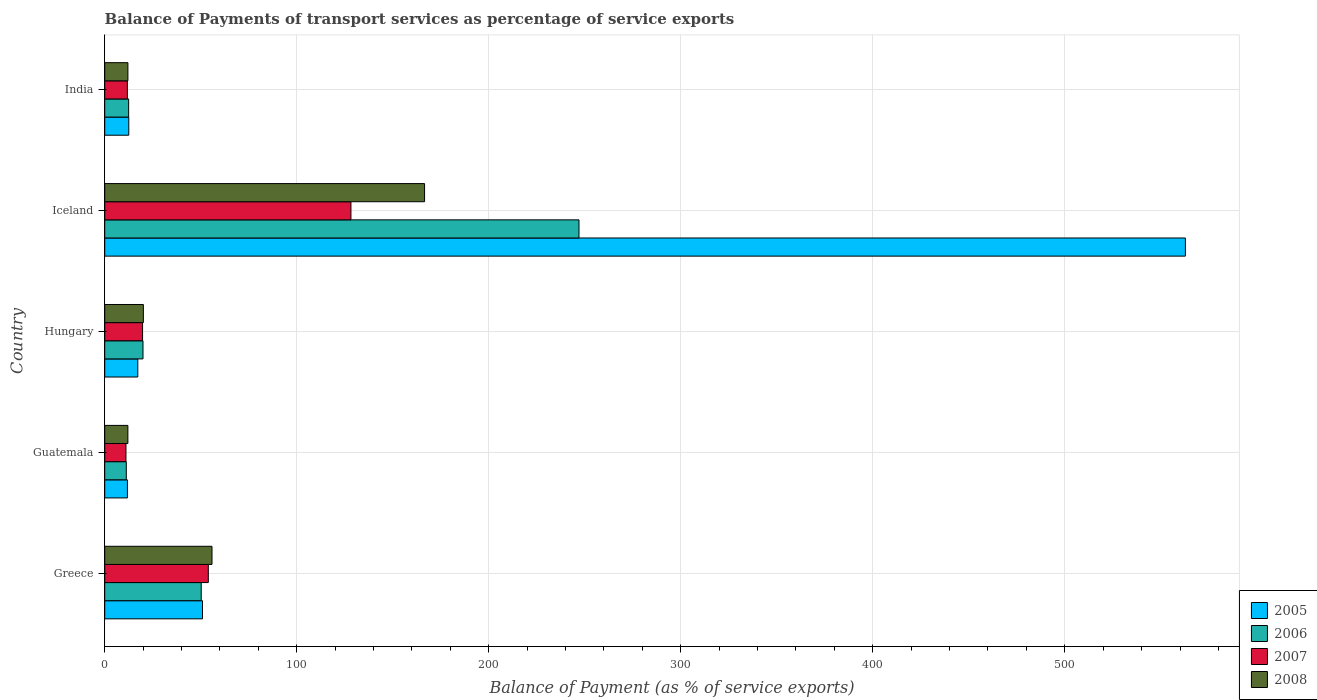Are the number of bars per tick equal to the number of legend labels?
Give a very brief answer. Yes. Are the number of bars on each tick of the Y-axis equal?
Your answer should be very brief. Yes. How many bars are there on the 2nd tick from the top?
Offer a very short reply. 4. How many bars are there on the 4th tick from the bottom?
Give a very brief answer. 4. What is the balance of payments of transport services in 2007 in Hungary?
Your answer should be very brief. 19.71. Across all countries, what is the maximum balance of payments of transport services in 2008?
Offer a terse response. 166.58. Across all countries, what is the minimum balance of payments of transport services in 2005?
Offer a terse response. 11.81. In which country was the balance of payments of transport services in 2008 maximum?
Your response must be concise. Iceland. In which country was the balance of payments of transport services in 2005 minimum?
Ensure brevity in your answer.  Guatemala. What is the total balance of payments of transport services in 2008 in the graph?
Your answer should be very brief. 266.71. What is the difference between the balance of payments of transport services in 2007 in Hungary and that in India?
Your response must be concise. 7.92. What is the difference between the balance of payments of transport services in 2007 in Greece and the balance of payments of transport services in 2008 in Iceland?
Keep it short and to the point. -112.63. What is the average balance of payments of transport services in 2006 per country?
Your answer should be compact. 68.18. What is the difference between the balance of payments of transport services in 2007 and balance of payments of transport services in 2006 in Iceland?
Provide a succinct answer. -118.77. In how many countries, is the balance of payments of transport services in 2006 greater than 260 %?
Your answer should be very brief. 0. What is the ratio of the balance of payments of transport services in 2005 in Guatemala to that in Hungary?
Provide a succinct answer. 0.69. Is the balance of payments of transport services in 2008 in Hungary less than that in India?
Your answer should be very brief. No. Is the difference between the balance of payments of transport services in 2007 in Greece and Iceland greater than the difference between the balance of payments of transport services in 2006 in Greece and Iceland?
Provide a short and direct response. Yes. What is the difference between the highest and the second highest balance of payments of transport services in 2008?
Ensure brevity in your answer.  110.71. What is the difference between the highest and the lowest balance of payments of transport services in 2005?
Offer a terse response. 550.99. In how many countries, is the balance of payments of transport services in 2008 greater than the average balance of payments of transport services in 2008 taken over all countries?
Your answer should be compact. 2. Is it the case that in every country, the sum of the balance of payments of transport services in 2006 and balance of payments of transport services in 2005 is greater than the sum of balance of payments of transport services in 2008 and balance of payments of transport services in 2007?
Your answer should be compact. No. Is it the case that in every country, the sum of the balance of payments of transport services in 2005 and balance of payments of transport services in 2007 is greater than the balance of payments of transport services in 2008?
Make the answer very short. Yes. What is the difference between two consecutive major ticks on the X-axis?
Keep it short and to the point. 100. Does the graph contain any zero values?
Offer a very short reply. No. Does the graph contain grids?
Provide a short and direct response. Yes. Where does the legend appear in the graph?
Your answer should be compact. Bottom right. How many legend labels are there?
Ensure brevity in your answer.  4. How are the legend labels stacked?
Your answer should be compact. Vertical. What is the title of the graph?
Give a very brief answer. Balance of Payments of transport services as percentage of service exports. What is the label or title of the X-axis?
Ensure brevity in your answer.  Balance of Payment (as % of service exports). What is the label or title of the Y-axis?
Provide a short and direct response. Country. What is the Balance of Payment (as % of service exports) in 2005 in Greece?
Give a very brief answer. 50.92. What is the Balance of Payment (as % of service exports) of 2006 in Greece?
Your response must be concise. 50.25. What is the Balance of Payment (as % of service exports) of 2007 in Greece?
Your answer should be compact. 53.95. What is the Balance of Payment (as % of service exports) in 2008 in Greece?
Your answer should be compact. 55.87. What is the Balance of Payment (as % of service exports) of 2005 in Guatemala?
Provide a succinct answer. 11.81. What is the Balance of Payment (as % of service exports) of 2006 in Guatemala?
Give a very brief answer. 11.24. What is the Balance of Payment (as % of service exports) in 2007 in Guatemala?
Your answer should be compact. 11.06. What is the Balance of Payment (as % of service exports) in 2008 in Guatemala?
Your answer should be compact. 12.06. What is the Balance of Payment (as % of service exports) of 2005 in Hungary?
Keep it short and to the point. 17.23. What is the Balance of Payment (as % of service exports) in 2006 in Hungary?
Offer a very short reply. 19.93. What is the Balance of Payment (as % of service exports) in 2007 in Hungary?
Provide a short and direct response. 19.71. What is the Balance of Payment (as % of service exports) of 2008 in Hungary?
Ensure brevity in your answer.  20.12. What is the Balance of Payment (as % of service exports) of 2005 in Iceland?
Give a very brief answer. 562.81. What is the Balance of Payment (as % of service exports) of 2006 in Iceland?
Offer a terse response. 247. What is the Balance of Payment (as % of service exports) of 2007 in Iceland?
Ensure brevity in your answer.  128.23. What is the Balance of Payment (as % of service exports) of 2008 in Iceland?
Provide a succinct answer. 166.58. What is the Balance of Payment (as % of service exports) in 2005 in India?
Your answer should be compact. 12.53. What is the Balance of Payment (as % of service exports) of 2006 in India?
Keep it short and to the point. 12.46. What is the Balance of Payment (as % of service exports) of 2007 in India?
Ensure brevity in your answer.  11.8. What is the Balance of Payment (as % of service exports) of 2008 in India?
Provide a succinct answer. 12.07. Across all countries, what is the maximum Balance of Payment (as % of service exports) of 2005?
Your answer should be very brief. 562.81. Across all countries, what is the maximum Balance of Payment (as % of service exports) in 2006?
Give a very brief answer. 247. Across all countries, what is the maximum Balance of Payment (as % of service exports) of 2007?
Your response must be concise. 128.23. Across all countries, what is the maximum Balance of Payment (as % of service exports) of 2008?
Your answer should be very brief. 166.58. Across all countries, what is the minimum Balance of Payment (as % of service exports) of 2005?
Give a very brief answer. 11.81. Across all countries, what is the minimum Balance of Payment (as % of service exports) in 2006?
Provide a short and direct response. 11.24. Across all countries, what is the minimum Balance of Payment (as % of service exports) of 2007?
Give a very brief answer. 11.06. Across all countries, what is the minimum Balance of Payment (as % of service exports) in 2008?
Give a very brief answer. 12.06. What is the total Balance of Payment (as % of service exports) in 2005 in the graph?
Make the answer very short. 655.29. What is the total Balance of Payment (as % of service exports) in 2006 in the graph?
Provide a short and direct response. 340.88. What is the total Balance of Payment (as % of service exports) of 2007 in the graph?
Your answer should be very brief. 224.75. What is the total Balance of Payment (as % of service exports) of 2008 in the graph?
Your response must be concise. 266.71. What is the difference between the Balance of Payment (as % of service exports) in 2005 in Greece and that in Guatemala?
Give a very brief answer. 39.1. What is the difference between the Balance of Payment (as % of service exports) of 2006 in Greece and that in Guatemala?
Ensure brevity in your answer.  39.02. What is the difference between the Balance of Payment (as % of service exports) of 2007 in Greece and that in Guatemala?
Your response must be concise. 42.9. What is the difference between the Balance of Payment (as % of service exports) of 2008 in Greece and that in Guatemala?
Make the answer very short. 43.81. What is the difference between the Balance of Payment (as % of service exports) in 2005 in Greece and that in Hungary?
Your response must be concise. 33.69. What is the difference between the Balance of Payment (as % of service exports) of 2006 in Greece and that in Hungary?
Offer a terse response. 30.32. What is the difference between the Balance of Payment (as % of service exports) of 2007 in Greece and that in Hungary?
Ensure brevity in your answer.  34.24. What is the difference between the Balance of Payment (as % of service exports) in 2008 in Greece and that in Hungary?
Your response must be concise. 35.75. What is the difference between the Balance of Payment (as % of service exports) of 2005 in Greece and that in Iceland?
Provide a short and direct response. -511.89. What is the difference between the Balance of Payment (as % of service exports) of 2006 in Greece and that in Iceland?
Your answer should be very brief. -196.74. What is the difference between the Balance of Payment (as % of service exports) of 2007 in Greece and that in Iceland?
Your answer should be very brief. -74.27. What is the difference between the Balance of Payment (as % of service exports) in 2008 in Greece and that in Iceland?
Your response must be concise. -110.71. What is the difference between the Balance of Payment (as % of service exports) of 2005 in Greece and that in India?
Offer a terse response. 38.39. What is the difference between the Balance of Payment (as % of service exports) in 2006 in Greece and that in India?
Keep it short and to the point. 37.79. What is the difference between the Balance of Payment (as % of service exports) of 2007 in Greece and that in India?
Provide a short and direct response. 42.16. What is the difference between the Balance of Payment (as % of service exports) of 2008 in Greece and that in India?
Make the answer very short. 43.79. What is the difference between the Balance of Payment (as % of service exports) in 2005 in Guatemala and that in Hungary?
Ensure brevity in your answer.  -5.42. What is the difference between the Balance of Payment (as % of service exports) of 2006 in Guatemala and that in Hungary?
Keep it short and to the point. -8.7. What is the difference between the Balance of Payment (as % of service exports) in 2007 in Guatemala and that in Hungary?
Your answer should be compact. -8.66. What is the difference between the Balance of Payment (as % of service exports) of 2008 in Guatemala and that in Hungary?
Your answer should be compact. -8.06. What is the difference between the Balance of Payment (as % of service exports) in 2005 in Guatemala and that in Iceland?
Provide a succinct answer. -550.99. What is the difference between the Balance of Payment (as % of service exports) of 2006 in Guatemala and that in Iceland?
Provide a succinct answer. -235.76. What is the difference between the Balance of Payment (as % of service exports) in 2007 in Guatemala and that in Iceland?
Make the answer very short. -117.17. What is the difference between the Balance of Payment (as % of service exports) of 2008 in Guatemala and that in Iceland?
Ensure brevity in your answer.  -154.52. What is the difference between the Balance of Payment (as % of service exports) of 2005 in Guatemala and that in India?
Your answer should be very brief. -0.71. What is the difference between the Balance of Payment (as % of service exports) in 2006 in Guatemala and that in India?
Provide a succinct answer. -1.22. What is the difference between the Balance of Payment (as % of service exports) in 2007 in Guatemala and that in India?
Keep it short and to the point. -0.74. What is the difference between the Balance of Payment (as % of service exports) in 2008 in Guatemala and that in India?
Make the answer very short. -0.01. What is the difference between the Balance of Payment (as % of service exports) of 2005 in Hungary and that in Iceland?
Provide a succinct answer. -545.58. What is the difference between the Balance of Payment (as % of service exports) in 2006 in Hungary and that in Iceland?
Keep it short and to the point. -227.06. What is the difference between the Balance of Payment (as % of service exports) of 2007 in Hungary and that in Iceland?
Ensure brevity in your answer.  -108.51. What is the difference between the Balance of Payment (as % of service exports) in 2008 in Hungary and that in Iceland?
Your response must be concise. -146.46. What is the difference between the Balance of Payment (as % of service exports) of 2005 in Hungary and that in India?
Your response must be concise. 4.7. What is the difference between the Balance of Payment (as % of service exports) in 2006 in Hungary and that in India?
Your answer should be very brief. 7.47. What is the difference between the Balance of Payment (as % of service exports) in 2007 in Hungary and that in India?
Your answer should be very brief. 7.92. What is the difference between the Balance of Payment (as % of service exports) in 2008 in Hungary and that in India?
Your response must be concise. 8.05. What is the difference between the Balance of Payment (as % of service exports) of 2005 in Iceland and that in India?
Keep it short and to the point. 550.28. What is the difference between the Balance of Payment (as % of service exports) in 2006 in Iceland and that in India?
Give a very brief answer. 234.54. What is the difference between the Balance of Payment (as % of service exports) of 2007 in Iceland and that in India?
Provide a short and direct response. 116.43. What is the difference between the Balance of Payment (as % of service exports) in 2008 in Iceland and that in India?
Your answer should be compact. 154.51. What is the difference between the Balance of Payment (as % of service exports) in 2005 in Greece and the Balance of Payment (as % of service exports) in 2006 in Guatemala?
Your answer should be very brief. 39.68. What is the difference between the Balance of Payment (as % of service exports) of 2005 in Greece and the Balance of Payment (as % of service exports) of 2007 in Guatemala?
Ensure brevity in your answer.  39.86. What is the difference between the Balance of Payment (as % of service exports) in 2005 in Greece and the Balance of Payment (as % of service exports) in 2008 in Guatemala?
Make the answer very short. 38.85. What is the difference between the Balance of Payment (as % of service exports) in 2006 in Greece and the Balance of Payment (as % of service exports) in 2007 in Guatemala?
Make the answer very short. 39.2. What is the difference between the Balance of Payment (as % of service exports) of 2006 in Greece and the Balance of Payment (as % of service exports) of 2008 in Guatemala?
Offer a very short reply. 38.19. What is the difference between the Balance of Payment (as % of service exports) in 2007 in Greece and the Balance of Payment (as % of service exports) in 2008 in Guatemala?
Your response must be concise. 41.89. What is the difference between the Balance of Payment (as % of service exports) in 2005 in Greece and the Balance of Payment (as % of service exports) in 2006 in Hungary?
Your answer should be compact. 30.98. What is the difference between the Balance of Payment (as % of service exports) in 2005 in Greece and the Balance of Payment (as % of service exports) in 2007 in Hungary?
Give a very brief answer. 31.2. What is the difference between the Balance of Payment (as % of service exports) of 2005 in Greece and the Balance of Payment (as % of service exports) of 2008 in Hungary?
Provide a succinct answer. 30.8. What is the difference between the Balance of Payment (as % of service exports) in 2006 in Greece and the Balance of Payment (as % of service exports) in 2007 in Hungary?
Your response must be concise. 30.54. What is the difference between the Balance of Payment (as % of service exports) of 2006 in Greece and the Balance of Payment (as % of service exports) of 2008 in Hungary?
Offer a very short reply. 30.13. What is the difference between the Balance of Payment (as % of service exports) of 2007 in Greece and the Balance of Payment (as % of service exports) of 2008 in Hungary?
Your answer should be compact. 33.83. What is the difference between the Balance of Payment (as % of service exports) in 2005 in Greece and the Balance of Payment (as % of service exports) in 2006 in Iceland?
Ensure brevity in your answer.  -196.08. What is the difference between the Balance of Payment (as % of service exports) of 2005 in Greece and the Balance of Payment (as % of service exports) of 2007 in Iceland?
Offer a very short reply. -77.31. What is the difference between the Balance of Payment (as % of service exports) of 2005 in Greece and the Balance of Payment (as % of service exports) of 2008 in Iceland?
Make the answer very short. -115.67. What is the difference between the Balance of Payment (as % of service exports) of 2006 in Greece and the Balance of Payment (as % of service exports) of 2007 in Iceland?
Make the answer very short. -77.97. What is the difference between the Balance of Payment (as % of service exports) of 2006 in Greece and the Balance of Payment (as % of service exports) of 2008 in Iceland?
Provide a short and direct response. -116.33. What is the difference between the Balance of Payment (as % of service exports) of 2007 in Greece and the Balance of Payment (as % of service exports) of 2008 in Iceland?
Make the answer very short. -112.63. What is the difference between the Balance of Payment (as % of service exports) in 2005 in Greece and the Balance of Payment (as % of service exports) in 2006 in India?
Give a very brief answer. 38.46. What is the difference between the Balance of Payment (as % of service exports) in 2005 in Greece and the Balance of Payment (as % of service exports) in 2007 in India?
Provide a succinct answer. 39.12. What is the difference between the Balance of Payment (as % of service exports) of 2005 in Greece and the Balance of Payment (as % of service exports) of 2008 in India?
Give a very brief answer. 38.84. What is the difference between the Balance of Payment (as % of service exports) in 2006 in Greece and the Balance of Payment (as % of service exports) in 2007 in India?
Make the answer very short. 38.46. What is the difference between the Balance of Payment (as % of service exports) of 2006 in Greece and the Balance of Payment (as % of service exports) of 2008 in India?
Offer a very short reply. 38.18. What is the difference between the Balance of Payment (as % of service exports) of 2007 in Greece and the Balance of Payment (as % of service exports) of 2008 in India?
Give a very brief answer. 41.88. What is the difference between the Balance of Payment (as % of service exports) in 2005 in Guatemala and the Balance of Payment (as % of service exports) in 2006 in Hungary?
Your answer should be compact. -8.12. What is the difference between the Balance of Payment (as % of service exports) of 2005 in Guatemala and the Balance of Payment (as % of service exports) of 2007 in Hungary?
Provide a succinct answer. -7.9. What is the difference between the Balance of Payment (as % of service exports) of 2005 in Guatemala and the Balance of Payment (as % of service exports) of 2008 in Hungary?
Give a very brief answer. -8.31. What is the difference between the Balance of Payment (as % of service exports) in 2006 in Guatemala and the Balance of Payment (as % of service exports) in 2007 in Hungary?
Provide a short and direct response. -8.47. What is the difference between the Balance of Payment (as % of service exports) of 2006 in Guatemala and the Balance of Payment (as % of service exports) of 2008 in Hungary?
Your answer should be compact. -8.88. What is the difference between the Balance of Payment (as % of service exports) in 2007 in Guatemala and the Balance of Payment (as % of service exports) in 2008 in Hungary?
Offer a terse response. -9.06. What is the difference between the Balance of Payment (as % of service exports) of 2005 in Guatemala and the Balance of Payment (as % of service exports) of 2006 in Iceland?
Give a very brief answer. -235.18. What is the difference between the Balance of Payment (as % of service exports) in 2005 in Guatemala and the Balance of Payment (as % of service exports) in 2007 in Iceland?
Ensure brevity in your answer.  -116.41. What is the difference between the Balance of Payment (as % of service exports) in 2005 in Guatemala and the Balance of Payment (as % of service exports) in 2008 in Iceland?
Your answer should be compact. -154.77. What is the difference between the Balance of Payment (as % of service exports) of 2006 in Guatemala and the Balance of Payment (as % of service exports) of 2007 in Iceland?
Give a very brief answer. -116.99. What is the difference between the Balance of Payment (as % of service exports) of 2006 in Guatemala and the Balance of Payment (as % of service exports) of 2008 in Iceland?
Your answer should be compact. -155.34. What is the difference between the Balance of Payment (as % of service exports) in 2007 in Guatemala and the Balance of Payment (as % of service exports) in 2008 in Iceland?
Give a very brief answer. -155.53. What is the difference between the Balance of Payment (as % of service exports) in 2005 in Guatemala and the Balance of Payment (as % of service exports) in 2006 in India?
Provide a short and direct response. -0.65. What is the difference between the Balance of Payment (as % of service exports) of 2005 in Guatemala and the Balance of Payment (as % of service exports) of 2007 in India?
Give a very brief answer. 0.02. What is the difference between the Balance of Payment (as % of service exports) in 2005 in Guatemala and the Balance of Payment (as % of service exports) in 2008 in India?
Offer a terse response. -0.26. What is the difference between the Balance of Payment (as % of service exports) of 2006 in Guatemala and the Balance of Payment (as % of service exports) of 2007 in India?
Offer a terse response. -0.56. What is the difference between the Balance of Payment (as % of service exports) in 2006 in Guatemala and the Balance of Payment (as % of service exports) in 2008 in India?
Offer a terse response. -0.83. What is the difference between the Balance of Payment (as % of service exports) in 2007 in Guatemala and the Balance of Payment (as % of service exports) in 2008 in India?
Provide a succinct answer. -1.02. What is the difference between the Balance of Payment (as % of service exports) in 2005 in Hungary and the Balance of Payment (as % of service exports) in 2006 in Iceland?
Your response must be concise. -229.77. What is the difference between the Balance of Payment (as % of service exports) in 2005 in Hungary and the Balance of Payment (as % of service exports) in 2007 in Iceland?
Your answer should be compact. -111. What is the difference between the Balance of Payment (as % of service exports) in 2005 in Hungary and the Balance of Payment (as % of service exports) in 2008 in Iceland?
Provide a succinct answer. -149.35. What is the difference between the Balance of Payment (as % of service exports) in 2006 in Hungary and the Balance of Payment (as % of service exports) in 2007 in Iceland?
Ensure brevity in your answer.  -108.29. What is the difference between the Balance of Payment (as % of service exports) in 2006 in Hungary and the Balance of Payment (as % of service exports) in 2008 in Iceland?
Provide a succinct answer. -146.65. What is the difference between the Balance of Payment (as % of service exports) in 2007 in Hungary and the Balance of Payment (as % of service exports) in 2008 in Iceland?
Give a very brief answer. -146.87. What is the difference between the Balance of Payment (as % of service exports) of 2005 in Hungary and the Balance of Payment (as % of service exports) of 2006 in India?
Your answer should be very brief. 4.77. What is the difference between the Balance of Payment (as % of service exports) of 2005 in Hungary and the Balance of Payment (as % of service exports) of 2007 in India?
Give a very brief answer. 5.43. What is the difference between the Balance of Payment (as % of service exports) in 2005 in Hungary and the Balance of Payment (as % of service exports) in 2008 in India?
Give a very brief answer. 5.16. What is the difference between the Balance of Payment (as % of service exports) in 2006 in Hungary and the Balance of Payment (as % of service exports) in 2007 in India?
Your answer should be compact. 8.14. What is the difference between the Balance of Payment (as % of service exports) of 2006 in Hungary and the Balance of Payment (as % of service exports) of 2008 in India?
Your answer should be very brief. 7.86. What is the difference between the Balance of Payment (as % of service exports) in 2007 in Hungary and the Balance of Payment (as % of service exports) in 2008 in India?
Provide a succinct answer. 7.64. What is the difference between the Balance of Payment (as % of service exports) of 2005 in Iceland and the Balance of Payment (as % of service exports) of 2006 in India?
Make the answer very short. 550.35. What is the difference between the Balance of Payment (as % of service exports) in 2005 in Iceland and the Balance of Payment (as % of service exports) in 2007 in India?
Your response must be concise. 551.01. What is the difference between the Balance of Payment (as % of service exports) of 2005 in Iceland and the Balance of Payment (as % of service exports) of 2008 in India?
Provide a succinct answer. 550.73. What is the difference between the Balance of Payment (as % of service exports) in 2006 in Iceland and the Balance of Payment (as % of service exports) in 2007 in India?
Offer a terse response. 235.2. What is the difference between the Balance of Payment (as % of service exports) in 2006 in Iceland and the Balance of Payment (as % of service exports) in 2008 in India?
Offer a terse response. 234.92. What is the difference between the Balance of Payment (as % of service exports) of 2007 in Iceland and the Balance of Payment (as % of service exports) of 2008 in India?
Make the answer very short. 116.15. What is the average Balance of Payment (as % of service exports) of 2005 per country?
Keep it short and to the point. 131.06. What is the average Balance of Payment (as % of service exports) of 2006 per country?
Offer a terse response. 68.18. What is the average Balance of Payment (as % of service exports) in 2007 per country?
Provide a succinct answer. 44.95. What is the average Balance of Payment (as % of service exports) in 2008 per country?
Give a very brief answer. 53.34. What is the difference between the Balance of Payment (as % of service exports) of 2005 and Balance of Payment (as % of service exports) of 2006 in Greece?
Your response must be concise. 0.66. What is the difference between the Balance of Payment (as % of service exports) in 2005 and Balance of Payment (as % of service exports) in 2007 in Greece?
Your answer should be very brief. -3.04. What is the difference between the Balance of Payment (as % of service exports) in 2005 and Balance of Payment (as % of service exports) in 2008 in Greece?
Offer a terse response. -4.95. What is the difference between the Balance of Payment (as % of service exports) of 2006 and Balance of Payment (as % of service exports) of 2007 in Greece?
Give a very brief answer. -3.7. What is the difference between the Balance of Payment (as % of service exports) of 2006 and Balance of Payment (as % of service exports) of 2008 in Greece?
Offer a terse response. -5.61. What is the difference between the Balance of Payment (as % of service exports) in 2007 and Balance of Payment (as % of service exports) in 2008 in Greece?
Give a very brief answer. -1.92. What is the difference between the Balance of Payment (as % of service exports) of 2005 and Balance of Payment (as % of service exports) of 2006 in Guatemala?
Offer a terse response. 0.58. What is the difference between the Balance of Payment (as % of service exports) in 2005 and Balance of Payment (as % of service exports) in 2007 in Guatemala?
Ensure brevity in your answer.  0.76. What is the difference between the Balance of Payment (as % of service exports) of 2005 and Balance of Payment (as % of service exports) of 2008 in Guatemala?
Offer a terse response. -0.25. What is the difference between the Balance of Payment (as % of service exports) of 2006 and Balance of Payment (as % of service exports) of 2007 in Guatemala?
Provide a succinct answer. 0.18. What is the difference between the Balance of Payment (as % of service exports) in 2006 and Balance of Payment (as % of service exports) in 2008 in Guatemala?
Your response must be concise. -0.82. What is the difference between the Balance of Payment (as % of service exports) of 2007 and Balance of Payment (as % of service exports) of 2008 in Guatemala?
Keep it short and to the point. -1.01. What is the difference between the Balance of Payment (as % of service exports) in 2005 and Balance of Payment (as % of service exports) in 2006 in Hungary?
Make the answer very short. -2.7. What is the difference between the Balance of Payment (as % of service exports) in 2005 and Balance of Payment (as % of service exports) in 2007 in Hungary?
Your answer should be very brief. -2.48. What is the difference between the Balance of Payment (as % of service exports) in 2005 and Balance of Payment (as % of service exports) in 2008 in Hungary?
Ensure brevity in your answer.  -2.89. What is the difference between the Balance of Payment (as % of service exports) in 2006 and Balance of Payment (as % of service exports) in 2007 in Hungary?
Your answer should be very brief. 0.22. What is the difference between the Balance of Payment (as % of service exports) of 2006 and Balance of Payment (as % of service exports) of 2008 in Hungary?
Provide a succinct answer. -0.19. What is the difference between the Balance of Payment (as % of service exports) in 2007 and Balance of Payment (as % of service exports) in 2008 in Hungary?
Give a very brief answer. -0.41. What is the difference between the Balance of Payment (as % of service exports) in 2005 and Balance of Payment (as % of service exports) in 2006 in Iceland?
Make the answer very short. 315.81. What is the difference between the Balance of Payment (as % of service exports) of 2005 and Balance of Payment (as % of service exports) of 2007 in Iceland?
Your response must be concise. 434.58. What is the difference between the Balance of Payment (as % of service exports) in 2005 and Balance of Payment (as % of service exports) in 2008 in Iceland?
Ensure brevity in your answer.  396.23. What is the difference between the Balance of Payment (as % of service exports) in 2006 and Balance of Payment (as % of service exports) in 2007 in Iceland?
Offer a terse response. 118.77. What is the difference between the Balance of Payment (as % of service exports) of 2006 and Balance of Payment (as % of service exports) of 2008 in Iceland?
Your response must be concise. 80.42. What is the difference between the Balance of Payment (as % of service exports) of 2007 and Balance of Payment (as % of service exports) of 2008 in Iceland?
Your response must be concise. -38.35. What is the difference between the Balance of Payment (as % of service exports) in 2005 and Balance of Payment (as % of service exports) in 2006 in India?
Give a very brief answer. 0.07. What is the difference between the Balance of Payment (as % of service exports) in 2005 and Balance of Payment (as % of service exports) in 2007 in India?
Your answer should be very brief. 0.73. What is the difference between the Balance of Payment (as % of service exports) in 2005 and Balance of Payment (as % of service exports) in 2008 in India?
Keep it short and to the point. 0.45. What is the difference between the Balance of Payment (as % of service exports) in 2006 and Balance of Payment (as % of service exports) in 2007 in India?
Your answer should be very brief. 0.66. What is the difference between the Balance of Payment (as % of service exports) in 2006 and Balance of Payment (as % of service exports) in 2008 in India?
Offer a terse response. 0.39. What is the difference between the Balance of Payment (as % of service exports) in 2007 and Balance of Payment (as % of service exports) in 2008 in India?
Make the answer very short. -0.28. What is the ratio of the Balance of Payment (as % of service exports) in 2005 in Greece to that in Guatemala?
Keep it short and to the point. 4.31. What is the ratio of the Balance of Payment (as % of service exports) of 2006 in Greece to that in Guatemala?
Offer a terse response. 4.47. What is the ratio of the Balance of Payment (as % of service exports) of 2007 in Greece to that in Guatemala?
Offer a terse response. 4.88. What is the ratio of the Balance of Payment (as % of service exports) in 2008 in Greece to that in Guatemala?
Offer a terse response. 4.63. What is the ratio of the Balance of Payment (as % of service exports) in 2005 in Greece to that in Hungary?
Offer a terse response. 2.96. What is the ratio of the Balance of Payment (as % of service exports) in 2006 in Greece to that in Hungary?
Provide a short and direct response. 2.52. What is the ratio of the Balance of Payment (as % of service exports) of 2007 in Greece to that in Hungary?
Your answer should be very brief. 2.74. What is the ratio of the Balance of Payment (as % of service exports) in 2008 in Greece to that in Hungary?
Make the answer very short. 2.78. What is the ratio of the Balance of Payment (as % of service exports) in 2005 in Greece to that in Iceland?
Keep it short and to the point. 0.09. What is the ratio of the Balance of Payment (as % of service exports) in 2006 in Greece to that in Iceland?
Offer a terse response. 0.2. What is the ratio of the Balance of Payment (as % of service exports) of 2007 in Greece to that in Iceland?
Make the answer very short. 0.42. What is the ratio of the Balance of Payment (as % of service exports) of 2008 in Greece to that in Iceland?
Offer a very short reply. 0.34. What is the ratio of the Balance of Payment (as % of service exports) in 2005 in Greece to that in India?
Offer a terse response. 4.06. What is the ratio of the Balance of Payment (as % of service exports) of 2006 in Greece to that in India?
Ensure brevity in your answer.  4.03. What is the ratio of the Balance of Payment (as % of service exports) in 2007 in Greece to that in India?
Give a very brief answer. 4.57. What is the ratio of the Balance of Payment (as % of service exports) in 2008 in Greece to that in India?
Make the answer very short. 4.63. What is the ratio of the Balance of Payment (as % of service exports) in 2005 in Guatemala to that in Hungary?
Your response must be concise. 0.69. What is the ratio of the Balance of Payment (as % of service exports) in 2006 in Guatemala to that in Hungary?
Your answer should be very brief. 0.56. What is the ratio of the Balance of Payment (as % of service exports) in 2007 in Guatemala to that in Hungary?
Keep it short and to the point. 0.56. What is the ratio of the Balance of Payment (as % of service exports) of 2008 in Guatemala to that in Hungary?
Your response must be concise. 0.6. What is the ratio of the Balance of Payment (as % of service exports) in 2005 in Guatemala to that in Iceland?
Provide a succinct answer. 0.02. What is the ratio of the Balance of Payment (as % of service exports) in 2006 in Guatemala to that in Iceland?
Give a very brief answer. 0.05. What is the ratio of the Balance of Payment (as % of service exports) in 2007 in Guatemala to that in Iceland?
Your response must be concise. 0.09. What is the ratio of the Balance of Payment (as % of service exports) in 2008 in Guatemala to that in Iceland?
Your answer should be compact. 0.07. What is the ratio of the Balance of Payment (as % of service exports) in 2005 in Guatemala to that in India?
Your answer should be very brief. 0.94. What is the ratio of the Balance of Payment (as % of service exports) in 2006 in Guatemala to that in India?
Ensure brevity in your answer.  0.9. What is the ratio of the Balance of Payment (as % of service exports) of 2007 in Guatemala to that in India?
Make the answer very short. 0.94. What is the ratio of the Balance of Payment (as % of service exports) of 2005 in Hungary to that in Iceland?
Your answer should be very brief. 0.03. What is the ratio of the Balance of Payment (as % of service exports) in 2006 in Hungary to that in Iceland?
Ensure brevity in your answer.  0.08. What is the ratio of the Balance of Payment (as % of service exports) in 2007 in Hungary to that in Iceland?
Give a very brief answer. 0.15. What is the ratio of the Balance of Payment (as % of service exports) of 2008 in Hungary to that in Iceland?
Give a very brief answer. 0.12. What is the ratio of the Balance of Payment (as % of service exports) of 2005 in Hungary to that in India?
Provide a short and direct response. 1.38. What is the ratio of the Balance of Payment (as % of service exports) of 2006 in Hungary to that in India?
Keep it short and to the point. 1.6. What is the ratio of the Balance of Payment (as % of service exports) in 2007 in Hungary to that in India?
Offer a terse response. 1.67. What is the ratio of the Balance of Payment (as % of service exports) of 2008 in Hungary to that in India?
Provide a short and direct response. 1.67. What is the ratio of the Balance of Payment (as % of service exports) of 2005 in Iceland to that in India?
Your answer should be compact. 44.92. What is the ratio of the Balance of Payment (as % of service exports) in 2006 in Iceland to that in India?
Keep it short and to the point. 19.82. What is the ratio of the Balance of Payment (as % of service exports) in 2007 in Iceland to that in India?
Your answer should be compact. 10.87. What is the ratio of the Balance of Payment (as % of service exports) in 2008 in Iceland to that in India?
Provide a short and direct response. 13.8. What is the difference between the highest and the second highest Balance of Payment (as % of service exports) of 2005?
Offer a terse response. 511.89. What is the difference between the highest and the second highest Balance of Payment (as % of service exports) of 2006?
Your answer should be very brief. 196.74. What is the difference between the highest and the second highest Balance of Payment (as % of service exports) in 2007?
Offer a terse response. 74.27. What is the difference between the highest and the second highest Balance of Payment (as % of service exports) in 2008?
Provide a succinct answer. 110.71. What is the difference between the highest and the lowest Balance of Payment (as % of service exports) in 2005?
Provide a short and direct response. 550.99. What is the difference between the highest and the lowest Balance of Payment (as % of service exports) of 2006?
Your answer should be compact. 235.76. What is the difference between the highest and the lowest Balance of Payment (as % of service exports) of 2007?
Provide a succinct answer. 117.17. What is the difference between the highest and the lowest Balance of Payment (as % of service exports) of 2008?
Make the answer very short. 154.52. 